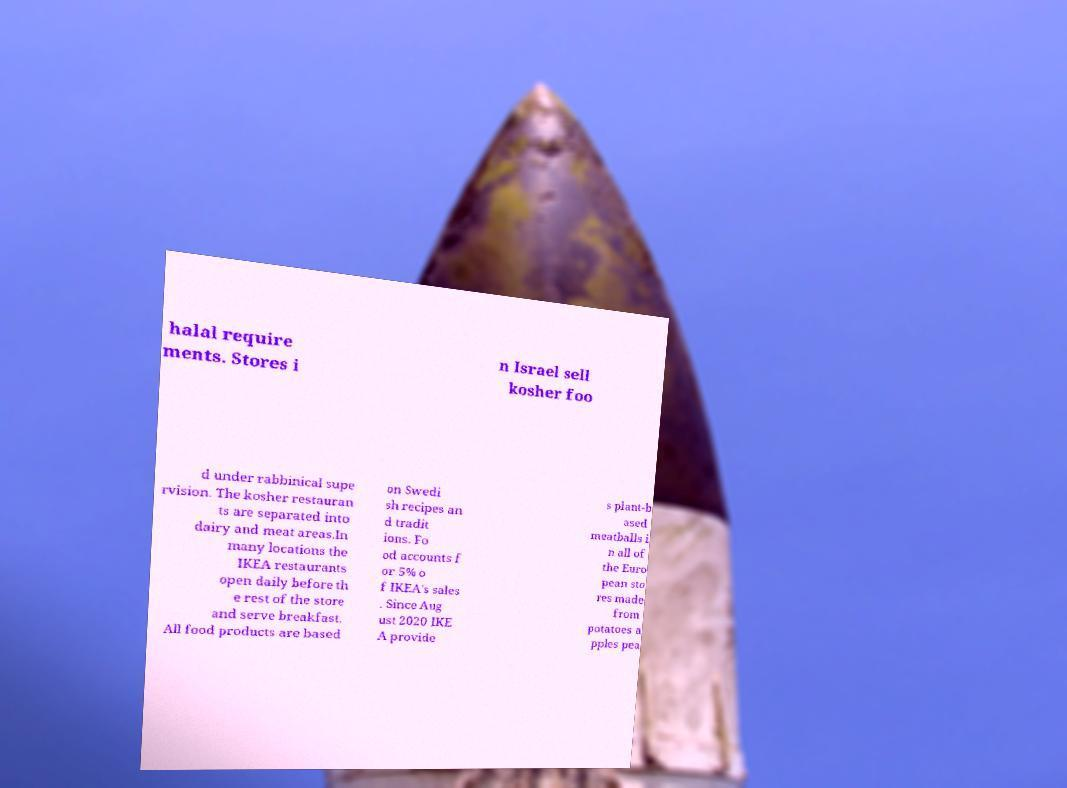Can you accurately transcribe the text from the provided image for me? halal require ments. Stores i n Israel sell kosher foo d under rabbinical supe rvision. The kosher restauran ts are separated into dairy and meat areas.In many locations the IKEA restaurants open daily before th e rest of the store and serve breakfast. All food products are based on Swedi sh recipes an d tradit ions. Fo od accounts f or 5% o f IKEA's sales . Since Aug ust 2020 IKE A provide s plant-b ased meatballs i n all of the Euro pean sto res made from potatoes a pples pea 